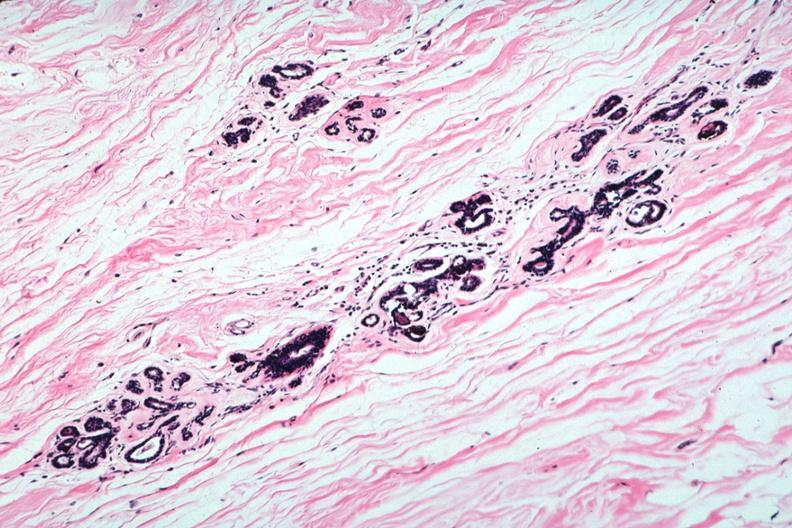does this image show atrophic lobules and normal connective tissue?
Answer the question using a single word or phrase. Yes 